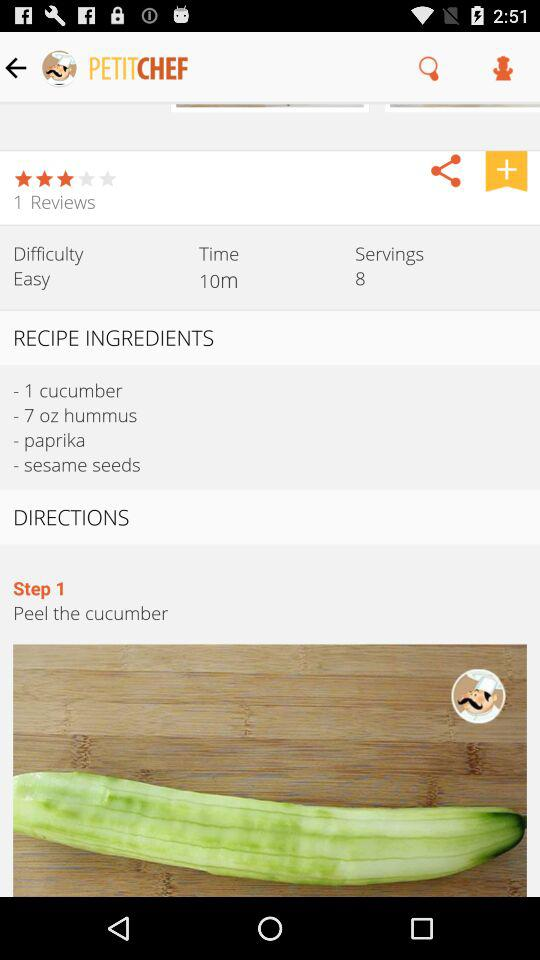What is the total time to prepare? The total time to prepare is 10 minutes. 